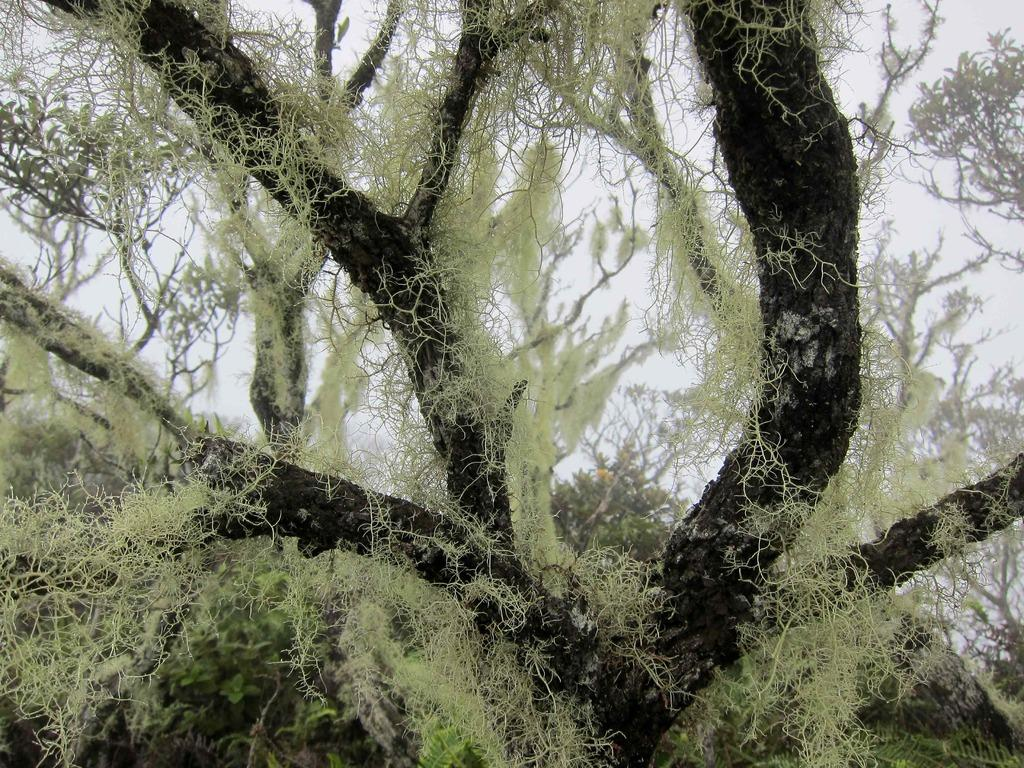What is located in the foreground of the picture? There is a tree in the foreground of the picture. What specific parts of the tree are visible? The stems of the tree are visible. How would you describe the background of the image? The background of the image is blurred. What else can be seen in the background besides the blurred area? There are trees in the background of the image. What is the condition of the sky in the picture? The sky is cloudy in the picture. What type of copper impulse can be seen running through the quartz in the image? There is no copper, impulse, or quartz present in the image. 